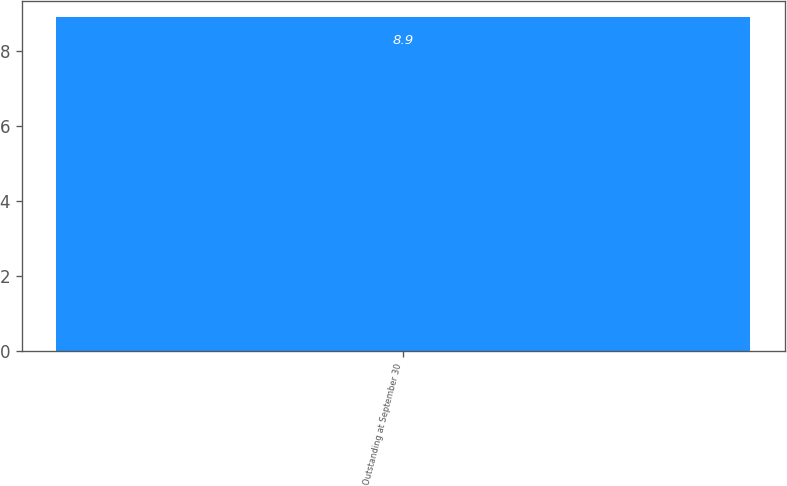Convert chart. <chart><loc_0><loc_0><loc_500><loc_500><bar_chart><fcel>Outstanding at September 30<nl><fcel>8.9<nl></chart> 